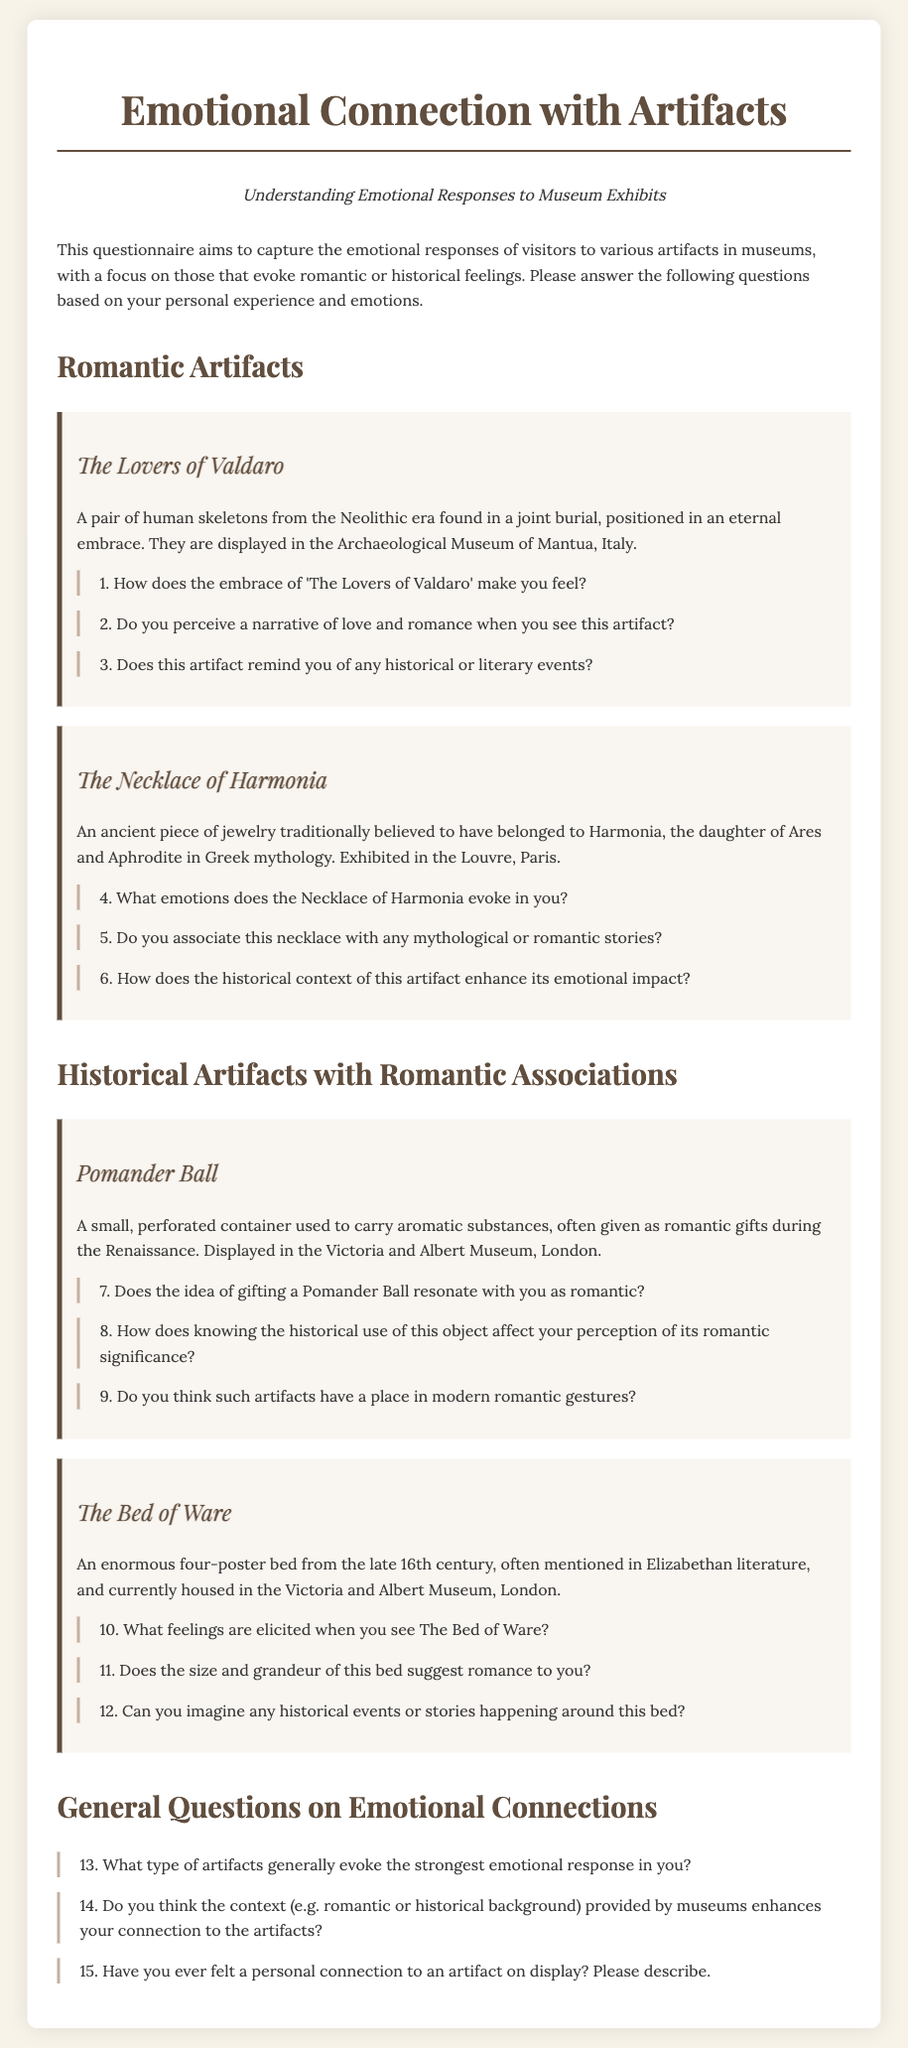What is the title of the questionnaire? The title of the questionnaire can be found at the beginning of the document.
Answer: Emotional Connection with Artifacts How many artifacts are classified under "Romantic Artifacts"? The section header indicates that there are two artifacts listed in that category.
Answer: 2 What is the name of the museum where "The Lovers of Valdaro" is displayed? The museum is mentioned in the description of this artifact in the document.
Answer: Archaeological Museum of Mantua What emotion does the Necklace of Harmonia evoke? The question directly asks about the emotional response to this specific artifact.
Answer: [Respondent's answer expected] Does the Pomander Ball have a romantic significance associated with its gifting? The question requires reasoning about the historical context and personal feelings toward gifting this object.
Answer: [Respondent's answer expected] What century does The Bed of Ware originate from? The century is specified in the description of the artifact in the document.
Answer: Late 16th century How many general questions about emotional connections are presented in the document? The number of questions listed under the "General Questions on Emotional Connections" is counted.
Answer: 3 What section includes questions about The Bed of Ware? The section headers guide readers to the location of the questions regarding this artifact.
Answer: Historical Artifacts with Romantic Associations What type of emotional responses does this questionnaire aim to capture? The introduction explains the purpose of the questionnaire regarding emotional responses to artifacts.
Answer: Romantic or historical feelings 